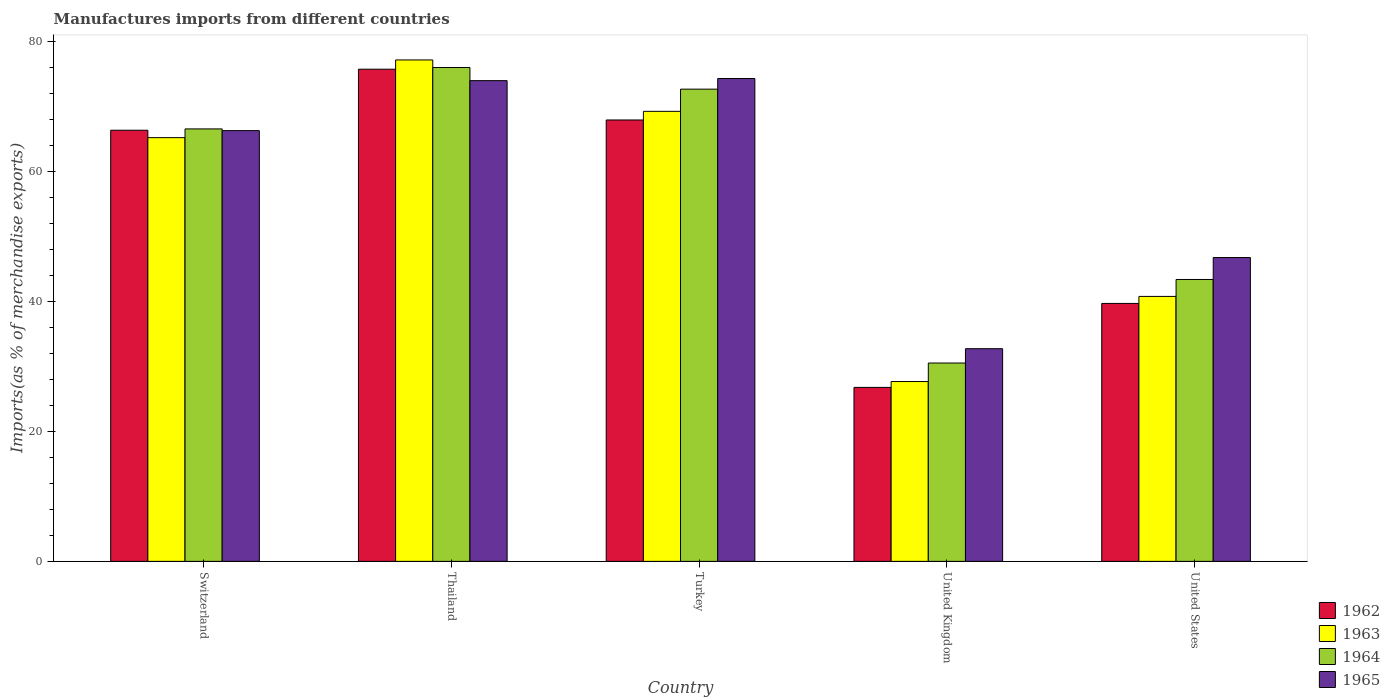How many different coloured bars are there?
Provide a succinct answer. 4. Are the number of bars on each tick of the X-axis equal?
Keep it short and to the point. Yes. How many bars are there on the 3rd tick from the left?
Provide a short and direct response. 4. How many bars are there on the 3rd tick from the right?
Your answer should be compact. 4. What is the label of the 2nd group of bars from the left?
Offer a very short reply. Thailand. What is the percentage of imports to different countries in 1964 in United Kingdom?
Ensure brevity in your answer.  30.5. Across all countries, what is the maximum percentage of imports to different countries in 1963?
Your response must be concise. 77.12. Across all countries, what is the minimum percentage of imports to different countries in 1965?
Your answer should be compact. 32.71. In which country was the percentage of imports to different countries in 1965 maximum?
Provide a succinct answer. Turkey. What is the total percentage of imports to different countries in 1962 in the graph?
Your response must be concise. 276.31. What is the difference between the percentage of imports to different countries in 1965 in Turkey and that in United States?
Offer a very short reply. 27.53. What is the difference between the percentage of imports to different countries in 1963 in Turkey and the percentage of imports to different countries in 1964 in Thailand?
Your response must be concise. -6.74. What is the average percentage of imports to different countries in 1962 per country?
Your answer should be compact. 55.26. What is the difference between the percentage of imports to different countries of/in 1965 and percentage of imports to different countries of/in 1964 in Turkey?
Ensure brevity in your answer.  1.64. In how many countries, is the percentage of imports to different countries in 1965 greater than 16 %?
Your answer should be very brief. 5. What is the ratio of the percentage of imports to different countries in 1965 in Switzerland to that in Turkey?
Offer a very short reply. 0.89. What is the difference between the highest and the second highest percentage of imports to different countries in 1964?
Give a very brief answer. 6.12. What is the difference between the highest and the lowest percentage of imports to different countries in 1963?
Your answer should be very brief. 49.46. In how many countries, is the percentage of imports to different countries in 1964 greater than the average percentage of imports to different countries in 1964 taken over all countries?
Offer a terse response. 3. Is the sum of the percentage of imports to different countries in 1964 in Switzerland and Turkey greater than the maximum percentage of imports to different countries in 1965 across all countries?
Provide a succinct answer. Yes. What does the 3rd bar from the left in Switzerland represents?
Provide a short and direct response. 1964. Is it the case that in every country, the sum of the percentage of imports to different countries in 1962 and percentage of imports to different countries in 1965 is greater than the percentage of imports to different countries in 1964?
Give a very brief answer. Yes. What is the difference between two consecutive major ticks on the Y-axis?
Offer a very short reply. 20. Are the values on the major ticks of Y-axis written in scientific E-notation?
Make the answer very short. No. Does the graph contain any zero values?
Your answer should be compact. No. Does the graph contain grids?
Offer a very short reply. No. Where does the legend appear in the graph?
Your answer should be very brief. Bottom right. How are the legend labels stacked?
Provide a succinct answer. Vertical. What is the title of the graph?
Your response must be concise. Manufactures imports from different countries. What is the label or title of the X-axis?
Your answer should be very brief. Country. What is the label or title of the Y-axis?
Provide a succinct answer. Imports(as % of merchandise exports). What is the Imports(as % of merchandise exports) of 1962 in Switzerland?
Your answer should be very brief. 66.31. What is the Imports(as % of merchandise exports) of 1963 in Switzerland?
Give a very brief answer. 65.16. What is the Imports(as % of merchandise exports) in 1964 in Switzerland?
Ensure brevity in your answer.  66.51. What is the Imports(as % of merchandise exports) of 1965 in Switzerland?
Provide a succinct answer. 66.24. What is the Imports(as % of merchandise exports) in 1962 in Thailand?
Provide a succinct answer. 75.69. What is the Imports(as % of merchandise exports) of 1963 in Thailand?
Offer a very short reply. 77.12. What is the Imports(as % of merchandise exports) in 1964 in Thailand?
Ensure brevity in your answer.  75.95. What is the Imports(as % of merchandise exports) of 1965 in Thailand?
Provide a succinct answer. 73.93. What is the Imports(as % of merchandise exports) in 1962 in Turkey?
Offer a very short reply. 67.88. What is the Imports(as % of merchandise exports) in 1963 in Turkey?
Offer a terse response. 69.21. What is the Imports(as % of merchandise exports) in 1964 in Turkey?
Keep it short and to the point. 72.62. What is the Imports(as % of merchandise exports) in 1965 in Turkey?
Keep it short and to the point. 74.26. What is the Imports(as % of merchandise exports) in 1962 in United Kingdom?
Provide a succinct answer. 26.76. What is the Imports(as % of merchandise exports) of 1963 in United Kingdom?
Offer a terse response. 27.66. What is the Imports(as % of merchandise exports) in 1964 in United Kingdom?
Give a very brief answer. 30.5. What is the Imports(as % of merchandise exports) of 1965 in United Kingdom?
Ensure brevity in your answer.  32.71. What is the Imports(as % of merchandise exports) in 1962 in United States?
Offer a very short reply. 39.67. What is the Imports(as % of merchandise exports) of 1963 in United States?
Make the answer very short. 40.75. What is the Imports(as % of merchandise exports) in 1964 in United States?
Provide a short and direct response. 43.35. What is the Imports(as % of merchandise exports) in 1965 in United States?
Offer a terse response. 46.73. Across all countries, what is the maximum Imports(as % of merchandise exports) in 1962?
Offer a terse response. 75.69. Across all countries, what is the maximum Imports(as % of merchandise exports) of 1963?
Give a very brief answer. 77.12. Across all countries, what is the maximum Imports(as % of merchandise exports) in 1964?
Give a very brief answer. 75.95. Across all countries, what is the maximum Imports(as % of merchandise exports) of 1965?
Offer a very short reply. 74.26. Across all countries, what is the minimum Imports(as % of merchandise exports) of 1962?
Your response must be concise. 26.76. Across all countries, what is the minimum Imports(as % of merchandise exports) of 1963?
Offer a very short reply. 27.66. Across all countries, what is the minimum Imports(as % of merchandise exports) in 1964?
Ensure brevity in your answer.  30.5. Across all countries, what is the minimum Imports(as % of merchandise exports) in 1965?
Give a very brief answer. 32.71. What is the total Imports(as % of merchandise exports) in 1962 in the graph?
Offer a very short reply. 276.31. What is the total Imports(as % of merchandise exports) in 1963 in the graph?
Ensure brevity in your answer.  279.9. What is the total Imports(as % of merchandise exports) of 1964 in the graph?
Your answer should be very brief. 288.94. What is the total Imports(as % of merchandise exports) in 1965 in the graph?
Offer a very short reply. 293.87. What is the difference between the Imports(as % of merchandise exports) of 1962 in Switzerland and that in Thailand?
Keep it short and to the point. -9.39. What is the difference between the Imports(as % of merchandise exports) in 1963 in Switzerland and that in Thailand?
Your answer should be compact. -11.95. What is the difference between the Imports(as % of merchandise exports) in 1964 in Switzerland and that in Thailand?
Give a very brief answer. -9.44. What is the difference between the Imports(as % of merchandise exports) of 1965 in Switzerland and that in Thailand?
Keep it short and to the point. -7.69. What is the difference between the Imports(as % of merchandise exports) of 1962 in Switzerland and that in Turkey?
Provide a succinct answer. -1.58. What is the difference between the Imports(as % of merchandise exports) of 1963 in Switzerland and that in Turkey?
Provide a succinct answer. -4.05. What is the difference between the Imports(as % of merchandise exports) of 1964 in Switzerland and that in Turkey?
Keep it short and to the point. -6.12. What is the difference between the Imports(as % of merchandise exports) in 1965 in Switzerland and that in Turkey?
Keep it short and to the point. -8.02. What is the difference between the Imports(as % of merchandise exports) in 1962 in Switzerland and that in United Kingdom?
Provide a short and direct response. 39.55. What is the difference between the Imports(as % of merchandise exports) of 1963 in Switzerland and that in United Kingdom?
Provide a succinct answer. 37.51. What is the difference between the Imports(as % of merchandise exports) of 1964 in Switzerland and that in United Kingdom?
Give a very brief answer. 36.01. What is the difference between the Imports(as % of merchandise exports) in 1965 in Switzerland and that in United Kingdom?
Offer a terse response. 33.54. What is the difference between the Imports(as % of merchandise exports) in 1962 in Switzerland and that in United States?
Make the answer very short. 26.64. What is the difference between the Imports(as % of merchandise exports) of 1963 in Switzerland and that in United States?
Make the answer very short. 24.42. What is the difference between the Imports(as % of merchandise exports) in 1964 in Switzerland and that in United States?
Your answer should be very brief. 23.15. What is the difference between the Imports(as % of merchandise exports) of 1965 in Switzerland and that in United States?
Ensure brevity in your answer.  19.52. What is the difference between the Imports(as % of merchandise exports) of 1962 in Thailand and that in Turkey?
Ensure brevity in your answer.  7.81. What is the difference between the Imports(as % of merchandise exports) of 1963 in Thailand and that in Turkey?
Keep it short and to the point. 7.9. What is the difference between the Imports(as % of merchandise exports) of 1964 in Thailand and that in Turkey?
Make the answer very short. 3.33. What is the difference between the Imports(as % of merchandise exports) of 1965 in Thailand and that in Turkey?
Your answer should be compact. -0.33. What is the difference between the Imports(as % of merchandise exports) in 1962 in Thailand and that in United Kingdom?
Provide a short and direct response. 48.94. What is the difference between the Imports(as % of merchandise exports) in 1963 in Thailand and that in United Kingdom?
Offer a very short reply. 49.46. What is the difference between the Imports(as % of merchandise exports) in 1964 in Thailand and that in United Kingdom?
Provide a short and direct response. 45.45. What is the difference between the Imports(as % of merchandise exports) in 1965 in Thailand and that in United Kingdom?
Your answer should be compact. 41.22. What is the difference between the Imports(as % of merchandise exports) of 1962 in Thailand and that in United States?
Provide a short and direct response. 36.02. What is the difference between the Imports(as % of merchandise exports) in 1963 in Thailand and that in United States?
Keep it short and to the point. 36.37. What is the difference between the Imports(as % of merchandise exports) in 1964 in Thailand and that in United States?
Provide a succinct answer. 32.6. What is the difference between the Imports(as % of merchandise exports) of 1965 in Thailand and that in United States?
Give a very brief answer. 27.2. What is the difference between the Imports(as % of merchandise exports) in 1962 in Turkey and that in United Kingdom?
Offer a very short reply. 41.13. What is the difference between the Imports(as % of merchandise exports) of 1963 in Turkey and that in United Kingdom?
Provide a succinct answer. 41.56. What is the difference between the Imports(as % of merchandise exports) in 1964 in Turkey and that in United Kingdom?
Your response must be concise. 42.12. What is the difference between the Imports(as % of merchandise exports) in 1965 in Turkey and that in United Kingdom?
Provide a short and direct response. 41.55. What is the difference between the Imports(as % of merchandise exports) in 1962 in Turkey and that in United States?
Offer a very short reply. 28.21. What is the difference between the Imports(as % of merchandise exports) of 1963 in Turkey and that in United States?
Ensure brevity in your answer.  28.47. What is the difference between the Imports(as % of merchandise exports) in 1964 in Turkey and that in United States?
Keep it short and to the point. 29.27. What is the difference between the Imports(as % of merchandise exports) in 1965 in Turkey and that in United States?
Your answer should be very brief. 27.53. What is the difference between the Imports(as % of merchandise exports) in 1962 in United Kingdom and that in United States?
Give a very brief answer. -12.91. What is the difference between the Imports(as % of merchandise exports) of 1963 in United Kingdom and that in United States?
Offer a very short reply. -13.09. What is the difference between the Imports(as % of merchandise exports) of 1964 in United Kingdom and that in United States?
Give a very brief answer. -12.85. What is the difference between the Imports(as % of merchandise exports) of 1965 in United Kingdom and that in United States?
Provide a short and direct response. -14.02. What is the difference between the Imports(as % of merchandise exports) of 1962 in Switzerland and the Imports(as % of merchandise exports) of 1963 in Thailand?
Your answer should be very brief. -10.81. What is the difference between the Imports(as % of merchandise exports) in 1962 in Switzerland and the Imports(as % of merchandise exports) in 1964 in Thailand?
Provide a short and direct response. -9.64. What is the difference between the Imports(as % of merchandise exports) in 1962 in Switzerland and the Imports(as % of merchandise exports) in 1965 in Thailand?
Your answer should be compact. -7.63. What is the difference between the Imports(as % of merchandise exports) of 1963 in Switzerland and the Imports(as % of merchandise exports) of 1964 in Thailand?
Offer a terse response. -10.78. What is the difference between the Imports(as % of merchandise exports) in 1963 in Switzerland and the Imports(as % of merchandise exports) in 1965 in Thailand?
Ensure brevity in your answer.  -8.77. What is the difference between the Imports(as % of merchandise exports) of 1964 in Switzerland and the Imports(as % of merchandise exports) of 1965 in Thailand?
Your response must be concise. -7.42. What is the difference between the Imports(as % of merchandise exports) of 1962 in Switzerland and the Imports(as % of merchandise exports) of 1963 in Turkey?
Provide a short and direct response. -2.91. What is the difference between the Imports(as % of merchandise exports) in 1962 in Switzerland and the Imports(as % of merchandise exports) in 1964 in Turkey?
Your answer should be very brief. -6.32. What is the difference between the Imports(as % of merchandise exports) in 1962 in Switzerland and the Imports(as % of merchandise exports) in 1965 in Turkey?
Provide a succinct answer. -7.96. What is the difference between the Imports(as % of merchandise exports) of 1963 in Switzerland and the Imports(as % of merchandise exports) of 1964 in Turkey?
Ensure brevity in your answer.  -7.46. What is the difference between the Imports(as % of merchandise exports) in 1963 in Switzerland and the Imports(as % of merchandise exports) in 1965 in Turkey?
Keep it short and to the point. -9.1. What is the difference between the Imports(as % of merchandise exports) of 1964 in Switzerland and the Imports(as % of merchandise exports) of 1965 in Turkey?
Your answer should be very brief. -7.75. What is the difference between the Imports(as % of merchandise exports) in 1962 in Switzerland and the Imports(as % of merchandise exports) in 1963 in United Kingdom?
Make the answer very short. 38.65. What is the difference between the Imports(as % of merchandise exports) of 1962 in Switzerland and the Imports(as % of merchandise exports) of 1964 in United Kingdom?
Your answer should be compact. 35.8. What is the difference between the Imports(as % of merchandise exports) in 1962 in Switzerland and the Imports(as % of merchandise exports) in 1965 in United Kingdom?
Your response must be concise. 33.6. What is the difference between the Imports(as % of merchandise exports) of 1963 in Switzerland and the Imports(as % of merchandise exports) of 1964 in United Kingdom?
Keep it short and to the point. 34.66. What is the difference between the Imports(as % of merchandise exports) in 1963 in Switzerland and the Imports(as % of merchandise exports) in 1965 in United Kingdom?
Offer a very short reply. 32.46. What is the difference between the Imports(as % of merchandise exports) in 1964 in Switzerland and the Imports(as % of merchandise exports) in 1965 in United Kingdom?
Give a very brief answer. 33.8. What is the difference between the Imports(as % of merchandise exports) in 1962 in Switzerland and the Imports(as % of merchandise exports) in 1963 in United States?
Your answer should be compact. 25.56. What is the difference between the Imports(as % of merchandise exports) in 1962 in Switzerland and the Imports(as % of merchandise exports) in 1964 in United States?
Ensure brevity in your answer.  22.95. What is the difference between the Imports(as % of merchandise exports) of 1962 in Switzerland and the Imports(as % of merchandise exports) of 1965 in United States?
Ensure brevity in your answer.  19.58. What is the difference between the Imports(as % of merchandise exports) in 1963 in Switzerland and the Imports(as % of merchandise exports) in 1964 in United States?
Your answer should be very brief. 21.81. What is the difference between the Imports(as % of merchandise exports) in 1963 in Switzerland and the Imports(as % of merchandise exports) in 1965 in United States?
Ensure brevity in your answer.  18.44. What is the difference between the Imports(as % of merchandise exports) of 1964 in Switzerland and the Imports(as % of merchandise exports) of 1965 in United States?
Your response must be concise. 19.78. What is the difference between the Imports(as % of merchandise exports) in 1962 in Thailand and the Imports(as % of merchandise exports) in 1963 in Turkey?
Your answer should be compact. 6.48. What is the difference between the Imports(as % of merchandise exports) in 1962 in Thailand and the Imports(as % of merchandise exports) in 1964 in Turkey?
Make the answer very short. 3.07. What is the difference between the Imports(as % of merchandise exports) of 1962 in Thailand and the Imports(as % of merchandise exports) of 1965 in Turkey?
Your answer should be compact. 1.43. What is the difference between the Imports(as % of merchandise exports) of 1963 in Thailand and the Imports(as % of merchandise exports) of 1964 in Turkey?
Keep it short and to the point. 4.49. What is the difference between the Imports(as % of merchandise exports) in 1963 in Thailand and the Imports(as % of merchandise exports) in 1965 in Turkey?
Provide a succinct answer. 2.85. What is the difference between the Imports(as % of merchandise exports) of 1964 in Thailand and the Imports(as % of merchandise exports) of 1965 in Turkey?
Keep it short and to the point. 1.69. What is the difference between the Imports(as % of merchandise exports) in 1962 in Thailand and the Imports(as % of merchandise exports) in 1963 in United Kingdom?
Provide a succinct answer. 48.04. What is the difference between the Imports(as % of merchandise exports) in 1962 in Thailand and the Imports(as % of merchandise exports) in 1964 in United Kingdom?
Provide a short and direct response. 45.19. What is the difference between the Imports(as % of merchandise exports) in 1962 in Thailand and the Imports(as % of merchandise exports) in 1965 in United Kingdom?
Your answer should be very brief. 42.99. What is the difference between the Imports(as % of merchandise exports) in 1963 in Thailand and the Imports(as % of merchandise exports) in 1964 in United Kingdom?
Keep it short and to the point. 46.61. What is the difference between the Imports(as % of merchandise exports) of 1963 in Thailand and the Imports(as % of merchandise exports) of 1965 in United Kingdom?
Your answer should be very brief. 44.41. What is the difference between the Imports(as % of merchandise exports) in 1964 in Thailand and the Imports(as % of merchandise exports) in 1965 in United Kingdom?
Provide a short and direct response. 43.24. What is the difference between the Imports(as % of merchandise exports) of 1962 in Thailand and the Imports(as % of merchandise exports) of 1963 in United States?
Make the answer very short. 34.95. What is the difference between the Imports(as % of merchandise exports) of 1962 in Thailand and the Imports(as % of merchandise exports) of 1964 in United States?
Give a very brief answer. 32.34. What is the difference between the Imports(as % of merchandise exports) in 1962 in Thailand and the Imports(as % of merchandise exports) in 1965 in United States?
Offer a terse response. 28.97. What is the difference between the Imports(as % of merchandise exports) in 1963 in Thailand and the Imports(as % of merchandise exports) in 1964 in United States?
Make the answer very short. 33.76. What is the difference between the Imports(as % of merchandise exports) in 1963 in Thailand and the Imports(as % of merchandise exports) in 1965 in United States?
Keep it short and to the point. 30.39. What is the difference between the Imports(as % of merchandise exports) in 1964 in Thailand and the Imports(as % of merchandise exports) in 1965 in United States?
Ensure brevity in your answer.  29.22. What is the difference between the Imports(as % of merchandise exports) in 1962 in Turkey and the Imports(as % of merchandise exports) in 1963 in United Kingdom?
Provide a succinct answer. 40.23. What is the difference between the Imports(as % of merchandise exports) in 1962 in Turkey and the Imports(as % of merchandise exports) in 1964 in United Kingdom?
Make the answer very short. 37.38. What is the difference between the Imports(as % of merchandise exports) of 1962 in Turkey and the Imports(as % of merchandise exports) of 1965 in United Kingdom?
Your response must be concise. 35.18. What is the difference between the Imports(as % of merchandise exports) of 1963 in Turkey and the Imports(as % of merchandise exports) of 1964 in United Kingdom?
Provide a succinct answer. 38.71. What is the difference between the Imports(as % of merchandise exports) in 1963 in Turkey and the Imports(as % of merchandise exports) in 1965 in United Kingdom?
Offer a terse response. 36.51. What is the difference between the Imports(as % of merchandise exports) of 1964 in Turkey and the Imports(as % of merchandise exports) of 1965 in United Kingdom?
Ensure brevity in your answer.  39.92. What is the difference between the Imports(as % of merchandise exports) of 1962 in Turkey and the Imports(as % of merchandise exports) of 1963 in United States?
Ensure brevity in your answer.  27.14. What is the difference between the Imports(as % of merchandise exports) in 1962 in Turkey and the Imports(as % of merchandise exports) in 1964 in United States?
Keep it short and to the point. 24.53. What is the difference between the Imports(as % of merchandise exports) in 1962 in Turkey and the Imports(as % of merchandise exports) in 1965 in United States?
Your answer should be compact. 21.16. What is the difference between the Imports(as % of merchandise exports) of 1963 in Turkey and the Imports(as % of merchandise exports) of 1964 in United States?
Keep it short and to the point. 25.86. What is the difference between the Imports(as % of merchandise exports) in 1963 in Turkey and the Imports(as % of merchandise exports) in 1965 in United States?
Provide a succinct answer. 22.49. What is the difference between the Imports(as % of merchandise exports) of 1964 in Turkey and the Imports(as % of merchandise exports) of 1965 in United States?
Offer a very short reply. 25.9. What is the difference between the Imports(as % of merchandise exports) in 1962 in United Kingdom and the Imports(as % of merchandise exports) in 1963 in United States?
Provide a succinct answer. -13.99. What is the difference between the Imports(as % of merchandise exports) of 1962 in United Kingdom and the Imports(as % of merchandise exports) of 1964 in United States?
Give a very brief answer. -16.6. What is the difference between the Imports(as % of merchandise exports) in 1962 in United Kingdom and the Imports(as % of merchandise exports) in 1965 in United States?
Ensure brevity in your answer.  -19.97. What is the difference between the Imports(as % of merchandise exports) in 1963 in United Kingdom and the Imports(as % of merchandise exports) in 1964 in United States?
Offer a terse response. -15.7. What is the difference between the Imports(as % of merchandise exports) in 1963 in United Kingdom and the Imports(as % of merchandise exports) in 1965 in United States?
Give a very brief answer. -19.07. What is the difference between the Imports(as % of merchandise exports) in 1964 in United Kingdom and the Imports(as % of merchandise exports) in 1965 in United States?
Provide a short and direct response. -16.22. What is the average Imports(as % of merchandise exports) in 1962 per country?
Give a very brief answer. 55.26. What is the average Imports(as % of merchandise exports) of 1963 per country?
Provide a succinct answer. 55.98. What is the average Imports(as % of merchandise exports) in 1964 per country?
Provide a short and direct response. 57.79. What is the average Imports(as % of merchandise exports) in 1965 per country?
Your answer should be very brief. 58.77. What is the difference between the Imports(as % of merchandise exports) in 1962 and Imports(as % of merchandise exports) in 1963 in Switzerland?
Make the answer very short. 1.14. What is the difference between the Imports(as % of merchandise exports) of 1962 and Imports(as % of merchandise exports) of 1964 in Switzerland?
Ensure brevity in your answer.  -0.2. What is the difference between the Imports(as % of merchandise exports) in 1962 and Imports(as % of merchandise exports) in 1965 in Switzerland?
Your answer should be compact. 0.06. What is the difference between the Imports(as % of merchandise exports) in 1963 and Imports(as % of merchandise exports) in 1964 in Switzerland?
Offer a very short reply. -1.34. What is the difference between the Imports(as % of merchandise exports) in 1963 and Imports(as % of merchandise exports) in 1965 in Switzerland?
Make the answer very short. -1.08. What is the difference between the Imports(as % of merchandise exports) in 1964 and Imports(as % of merchandise exports) in 1965 in Switzerland?
Your answer should be very brief. 0.26. What is the difference between the Imports(as % of merchandise exports) of 1962 and Imports(as % of merchandise exports) of 1963 in Thailand?
Provide a succinct answer. -1.42. What is the difference between the Imports(as % of merchandise exports) of 1962 and Imports(as % of merchandise exports) of 1964 in Thailand?
Offer a very short reply. -0.26. What is the difference between the Imports(as % of merchandise exports) of 1962 and Imports(as % of merchandise exports) of 1965 in Thailand?
Your response must be concise. 1.76. What is the difference between the Imports(as % of merchandise exports) in 1963 and Imports(as % of merchandise exports) in 1964 in Thailand?
Give a very brief answer. 1.17. What is the difference between the Imports(as % of merchandise exports) of 1963 and Imports(as % of merchandise exports) of 1965 in Thailand?
Offer a very short reply. 3.18. What is the difference between the Imports(as % of merchandise exports) in 1964 and Imports(as % of merchandise exports) in 1965 in Thailand?
Ensure brevity in your answer.  2.02. What is the difference between the Imports(as % of merchandise exports) in 1962 and Imports(as % of merchandise exports) in 1963 in Turkey?
Your answer should be compact. -1.33. What is the difference between the Imports(as % of merchandise exports) of 1962 and Imports(as % of merchandise exports) of 1964 in Turkey?
Offer a very short reply. -4.74. What is the difference between the Imports(as % of merchandise exports) of 1962 and Imports(as % of merchandise exports) of 1965 in Turkey?
Your response must be concise. -6.38. What is the difference between the Imports(as % of merchandise exports) of 1963 and Imports(as % of merchandise exports) of 1964 in Turkey?
Your response must be concise. -3.41. What is the difference between the Imports(as % of merchandise exports) in 1963 and Imports(as % of merchandise exports) in 1965 in Turkey?
Offer a very short reply. -5.05. What is the difference between the Imports(as % of merchandise exports) of 1964 and Imports(as % of merchandise exports) of 1965 in Turkey?
Give a very brief answer. -1.64. What is the difference between the Imports(as % of merchandise exports) in 1962 and Imports(as % of merchandise exports) in 1963 in United Kingdom?
Give a very brief answer. -0.9. What is the difference between the Imports(as % of merchandise exports) of 1962 and Imports(as % of merchandise exports) of 1964 in United Kingdom?
Ensure brevity in your answer.  -3.75. What is the difference between the Imports(as % of merchandise exports) in 1962 and Imports(as % of merchandise exports) in 1965 in United Kingdom?
Your answer should be very brief. -5.95. What is the difference between the Imports(as % of merchandise exports) in 1963 and Imports(as % of merchandise exports) in 1964 in United Kingdom?
Offer a terse response. -2.85. What is the difference between the Imports(as % of merchandise exports) in 1963 and Imports(as % of merchandise exports) in 1965 in United Kingdom?
Offer a terse response. -5.05. What is the difference between the Imports(as % of merchandise exports) in 1964 and Imports(as % of merchandise exports) in 1965 in United Kingdom?
Your response must be concise. -2.2. What is the difference between the Imports(as % of merchandise exports) of 1962 and Imports(as % of merchandise exports) of 1963 in United States?
Keep it short and to the point. -1.08. What is the difference between the Imports(as % of merchandise exports) in 1962 and Imports(as % of merchandise exports) in 1964 in United States?
Make the answer very short. -3.68. What is the difference between the Imports(as % of merchandise exports) in 1962 and Imports(as % of merchandise exports) in 1965 in United States?
Offer a very short reply. -7.06. What is the difference between the Imports(as % of merchandise exports) of 1963 and Imports(as % of merchandise exports) of 1964 in United States?
Give a very brief answer. -2.61. What is the difference between the Imports(as % of merchandise exports) of 1963 and Imports(as % of merchandise exports) of 1965 in United States?
Give a very brief answer. -5.98. What is the difference between the Imports(as % of merchandise exports) of 1964 and Imports(as % of merchandise exports) of 1965 in United States?
Your answer should be compact. -3.37. What is the ratio of the Imports(as % of merchandise exports) in 1962 in Switzerland to that in Thailand?
Make the answer very short. 0.88. What is the ratio of the Imports(as % of merchandise exports) in 1963 in Switzerland to that in Thailand?
Your answer should be very brief. 0.84. What is the ratio of the Imports(as % of merchandise exports) of 1964 in Switzerland to that in Thailand?
Provide a short and direct response. 0.88. What is the ratio of the Imports(as % of merchandise exports) of 1965 in Switzerland to that in Thailand?
Your answer should be very brief. 0.9. What is the ratio of the Imports(as % of merchandise exports) of 1962 in Switzerland to that in Turkey?
Offer a terse response. 0.98. What is the ratio of the Imports(as % of merchandise exports) in 1963 in Switzerland to that in Turkey?
Offer a terse response. 0.94. What is the ratio of the Imports(as % of merchandise exports) of 1964 in Switzerland to that in Turkey?
Your response must be concise. 0.92. What is the ratio of the Imports(as % of merchandise exports) of 1965 in Switzerland to that in Turkey?
Your answer should be very brief. 0.89. What is the ratio of the Imports(as % of merchandise exports) of 1962 in Switzerland to that in United Kingdom?
Make the answer very short. 2.48. What is the ratio of the Imports(as % of merchandise exports) of 1963 in Switzerland to that in United Kingdom?
Give a very brief answer. 2.36. What is the ratio of the Imports(as % of merchandise exports) in 1964 in Switzerland to that in United Kingdom?
Keep it short and to the point. 2.18. What is the ratio of the Imports(as % of merchandise exports) of 1965 in Switzerland to that in United Kingdom?
Make the answer very short. 2.03. What is the ratio of the Imports(as % of merchandise exports) in 1962 in Switzerland to that in United States?
Make the answer very short. 1.67. What is the ratio of the Imports(as % of merchandise exports) of 1963 in Switzerland to that in United States?
Keep it short and to the point. 1.6. What is the ratio of the Imports(as % of merchandise exports) of 1964 in Switzerland to that in United States?
Give a very brief answer. 1.53. What is the ratio of the Imports(as % of merchandise exports) of 1965 in Switzerland to that in United States?
Your response must be concise. 1.42. What is the ratio of the Imports(as % of merchandise exports) in 1962 in Thailand to that in Turkey?
Give a very brief answer. 1.11. What is the ratio of the Imports(as % of merchandise exports) in 1963 in Thailand to that in Turkey?
Make the answer very short. 1.11. What is the ratio of the Imports(as % of merchandise exports) in 1964 in Thailand to that in Turkey?
Provide a succinct answer. 1.05. What is the ratio of the Imports(as % of merchandise exports) of 1965 in Thailand to that in Turkey?
Make the answer very short. 1. What is the ratio of the Imports(as % of merchandise exports) in 1962 in Thailand to that in United Kingdom?
Your answer should be compact. 2.83. What is the ratio of the Imports(as % of merchandise exports) in 1963 in Thailand to that in United Kingdom?
Ensure brevity in your answer.  2.79. What is the ratio of the Imports(as % of merchandise exports) of 1964 in Thailand to that in United Kingdom?
Offer a very short reply. 2.49. What is the ratio of the Imports(as % of merchandise exports) in 1965 in Thailand to that in United Kingdom?
Keep it short and to the point. 2.26. What is the ratio of the Imports(as % of merchandise exports) in 1962 in Thailand to that in United States?
Keep it short and to the point. 1.91. What is the ratio of the Imports(as % of merchandise exports) of 1963 in Thailand to that in United States?
Your answer should be very brief. 1.89. What is the ratio of the Imports(as % of merchandise exports) of 1964 in Thailand to that in United States?
Give a very brief answer. 1.75. What is the ratio of the Imports(as % of merchandise exports) of 1965 in Thailand to that in United States?
Your response must be concise. 1.58. What is the ratio of the Imports(as % of merchandise exports) in 1962 in Turkey to that in United Kingdom?
Make the answer very short. 2.54. What is the ratio of the Imports(as % of merchandise exports) of 1963 in Turkey to that in United Kingdom?
Your answer should be very brief. 2.5. What is the ratio of the Imports(as % of merchandise exports) of 1964 in Turkey to that in United Kingdom?
Your answer should be very brief. 2.38. What is the ratio of the Imports(as % of merchandise exports) of 1965 in Turkey to that in United Kingdom?
Offer a terse response. 2.27. What is the ratio of the Imports(as % of merchandise exports) in 1962 in Turkey to that in United States?
Your answer should be compact. 1.71. What is the ratio of the Imports(as % of merchandise exports) in 1963 in Turkey to that in United States?
Offer a terse response. 1.7. What is the ratio of the Imports(as % of merchandise exports) in 1964 in Turkey to that in United States?
Keep it short and to the point. 1.68. What is the ratio of the Imports(as % of merchandise exports) of 1965 in Turkey to that in United States?
Offer a terse response. 1.59. What is the ratio of the Imports(as % of merchandise exports) in 1962 in United Kingdom to that in United States?
Keep it short and to the point. 0.67. What is the ratio of the Imports(as % of merchandise exports) of 1963 in United Kingdom to that in United States?
Make the answer very short. 0.68. What is the ratio of the Imports(as % of merchandise exports) in 1964 in United Kingdom to that in United States?
Ensure brevity in your answer.  0.7. What is the ratio of the Imports(as % of merchandise exports) in 1965 in United Kingdom to that in United States?
Provide a succinct answer. 0.7. What is the difference between the highest and the second highest Imports(as % of merchandise exports) of 1962?
Make the answer very short. 7.81. What is the difference between the highest and the second highest Imports(as % of merchandise exports) of 1963?
Give a very brief answer. 7.9. What is the difference between the highest and the second highest Imports(as % of merchandise exports) in 1964?
Offer a terse response. 3.33. What is the difference between the highest and the second highest Imports(as % of merchandise exports) of 1965?
Provide a short and direct response. 0.33. What is the difference between the highest and the lowest Imports(as % of merchandise exports) of 1962?
Provide a succinct answer. 48.94. What is the difference between the highest and the lowest Imports(as % of merchandise exports) of 1963?
Your answer should be very brief. 49.46. What is the difference between the highest and the lowest Imports(as % of merchandise exports) of 1964?
Provide a short and direct response. 45.45. What is the difference between the highest and the lowest Imports(as % of merchandise exports) in 1965?
Offer a very short reply. 41.55. 